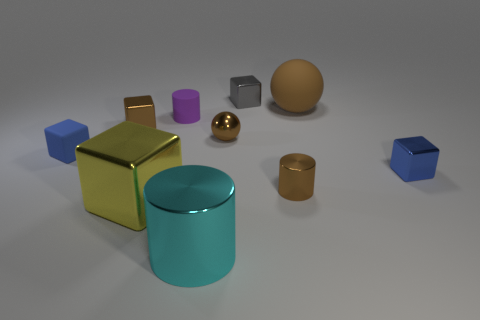Subtract all tiny brown blocks. How many blocks are left? 4 Subtract 1 blocks. How many blocks are left? 4 Subtract all brown blocks. How many blocks are left? 4 Subtract all purple cubes. Subtract all gray spheres. How many cubes are left? 5 Subtract all spheres. How many objects are left? 8 Add 4 cyan metallic things. How many cyan metallic things exist? 5 Subtract 0 green cubes. How many objects are left? 10 Subtract all tiny brown things. Subtract all large gray rubber spheres. How many objects are left? 7 Add 2 brown blocks. How many brown blocks are left? 3 